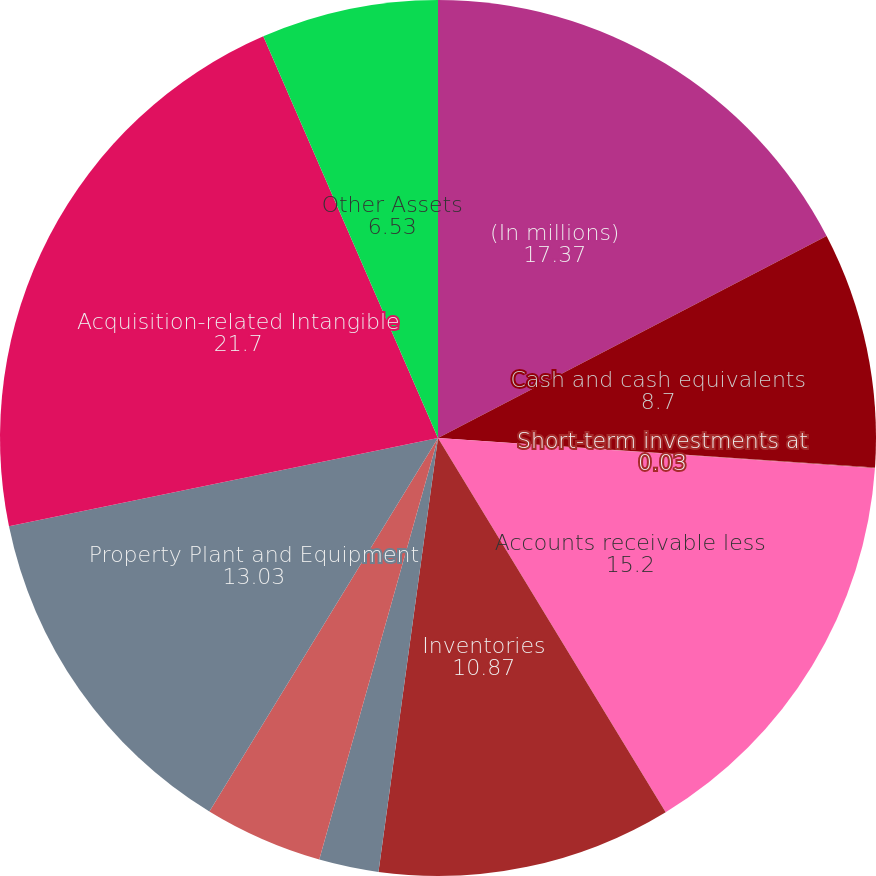<chart> <loc_0><loc_0><loc_500><loc_500><pie_chart><fcel>(In millions)<fcel>Cash and cash equivalents<fcel>Short-term investments at<fcel>Accounts receivable less<fcel>Inventories<fcel>Deferred tax assets<fcel>Other current assets<fcel>Property Plant and Equipment<fcel>Acquisition-related Intangible<fcel>Other Assets<nl><fcel>17.37%<fcel>8.7%<fcel>0.03%<fcel>15.2%<fcel>10.87%<fcel>2.2%<fcel>4.37%<fcel>13.03%<fcel>21.7%<fcel>6.53%<nl></chart> 